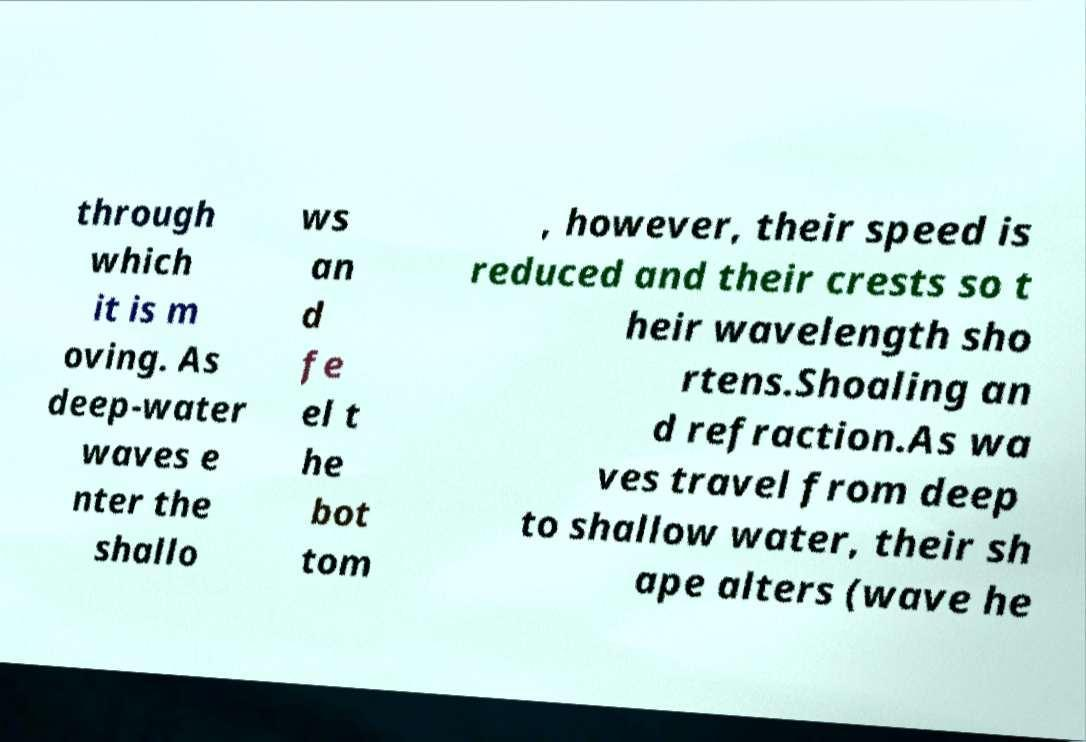Please identify and transcribe the text found in this image. through which it is m oving. As deep-water waves e nter the shallo ws an d fe el t he bot tom , however, their speed is reduced and their crests so t heir wavelength sho rtens.Shoaling an d refraction.As wa ves travel from deep to shallow water, their sh ape alters (wave he 